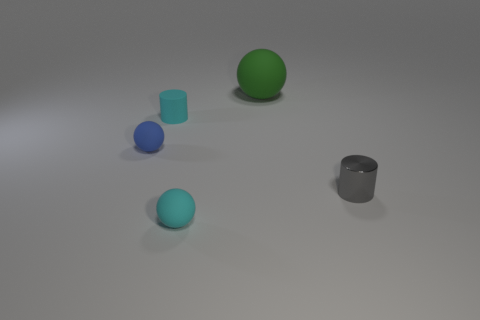Subtract all small cyan rubber spheres. How many spheres are left? 2 Subtract 1 cylinders. How many cylinders are left? 1 Add 2 big blue metallic blocks. How many objects exist? 7 Subtract all gray cylinders. How many cylinders are left? 1 Subtract all cylinders. How many objects are left? 3 Subtract all small cyan balls. Subtract all cyan matte balls. How many objects are left? 3 Add 1 small metallic cylinders. How many small metallic cylinders are left? 2 Add 1 small purple cubes. How many small purple cubes exist? 1 Subtract 0 gray blocks. How many objects are left? 5 Subtract all purple balls. Subtract all gray blocks. How many balls are left? 3 